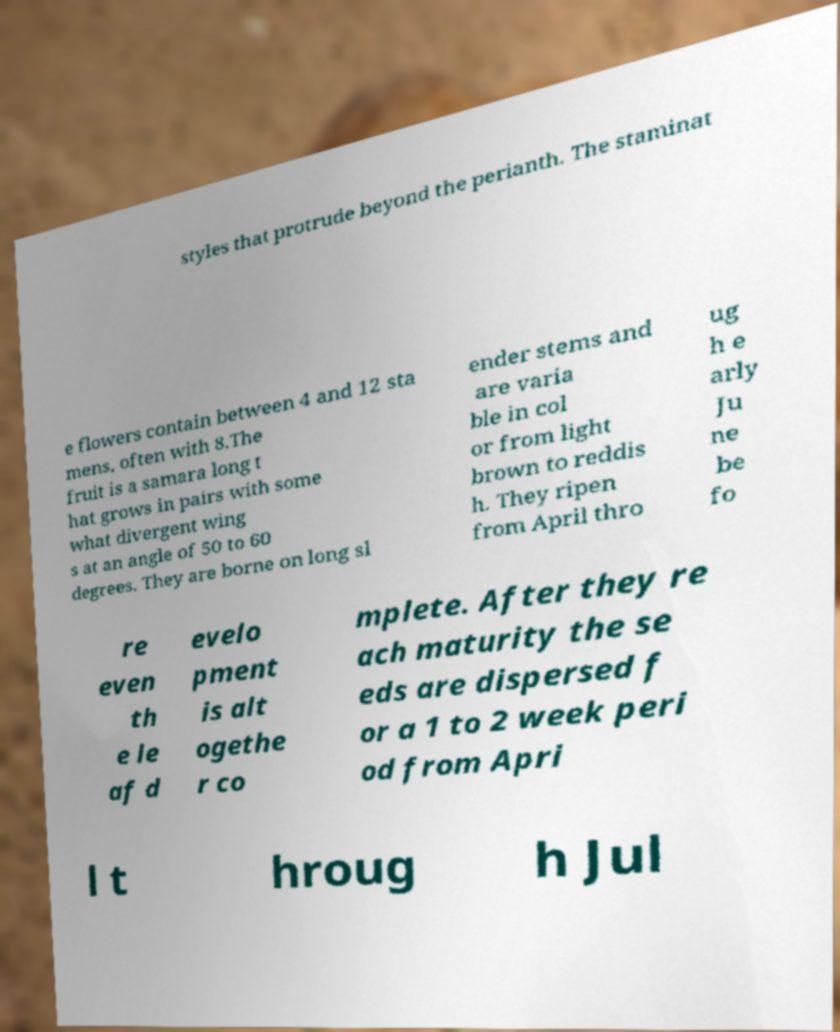Can you read and provide the text displayed in the image?This photo seems to have some interesting text. Can you extract and type it out for me? styles that protrude beyond the perianth. The staminat e flowers contain between 4 and 12 sta mens, often with 8.The fruit is a samara long t hat grows in pairs with some what divergent wing s at an angle of 50 to 60 degrees. They are borne on long sl ender stems and are varia ble in col or from light brown to reddis h. They ripen from April thro ug h e arly Ju ne be fo re even th e le af d evelo pment is alt ogethe r co mplete. After they re ach maturity the se eds are dispersed f or a 1 to 2 week peri od from Apri l t hroug h Jul 